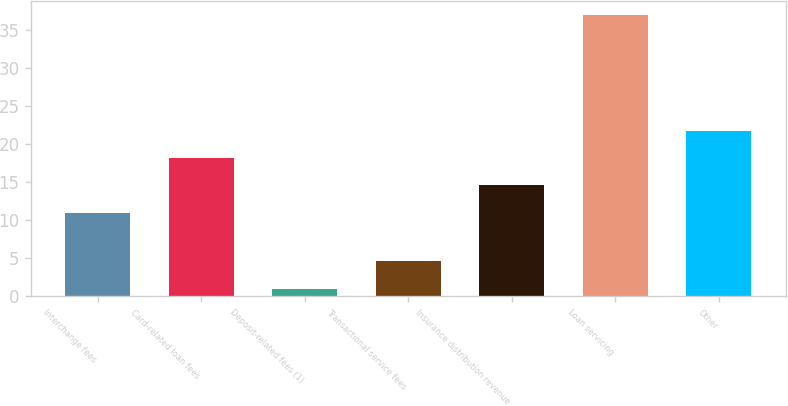Convert chart. <chart><loc_0><loc_0><loc_500><loc_500><bar_chart><fcel>Interchange fees<fcel>Card-related loan fees<fcel>Deposit-related fees (1)<fcel>Transactional service fees<fcel>Insurance distribution revenue<fcel>Loan servicing<fcel>Other<nl><fcel>11<fcel>18.2<fcel>1<fcel>4.6<fcel>14.6<fcel>37<fcel>21.8<nl></chart> 